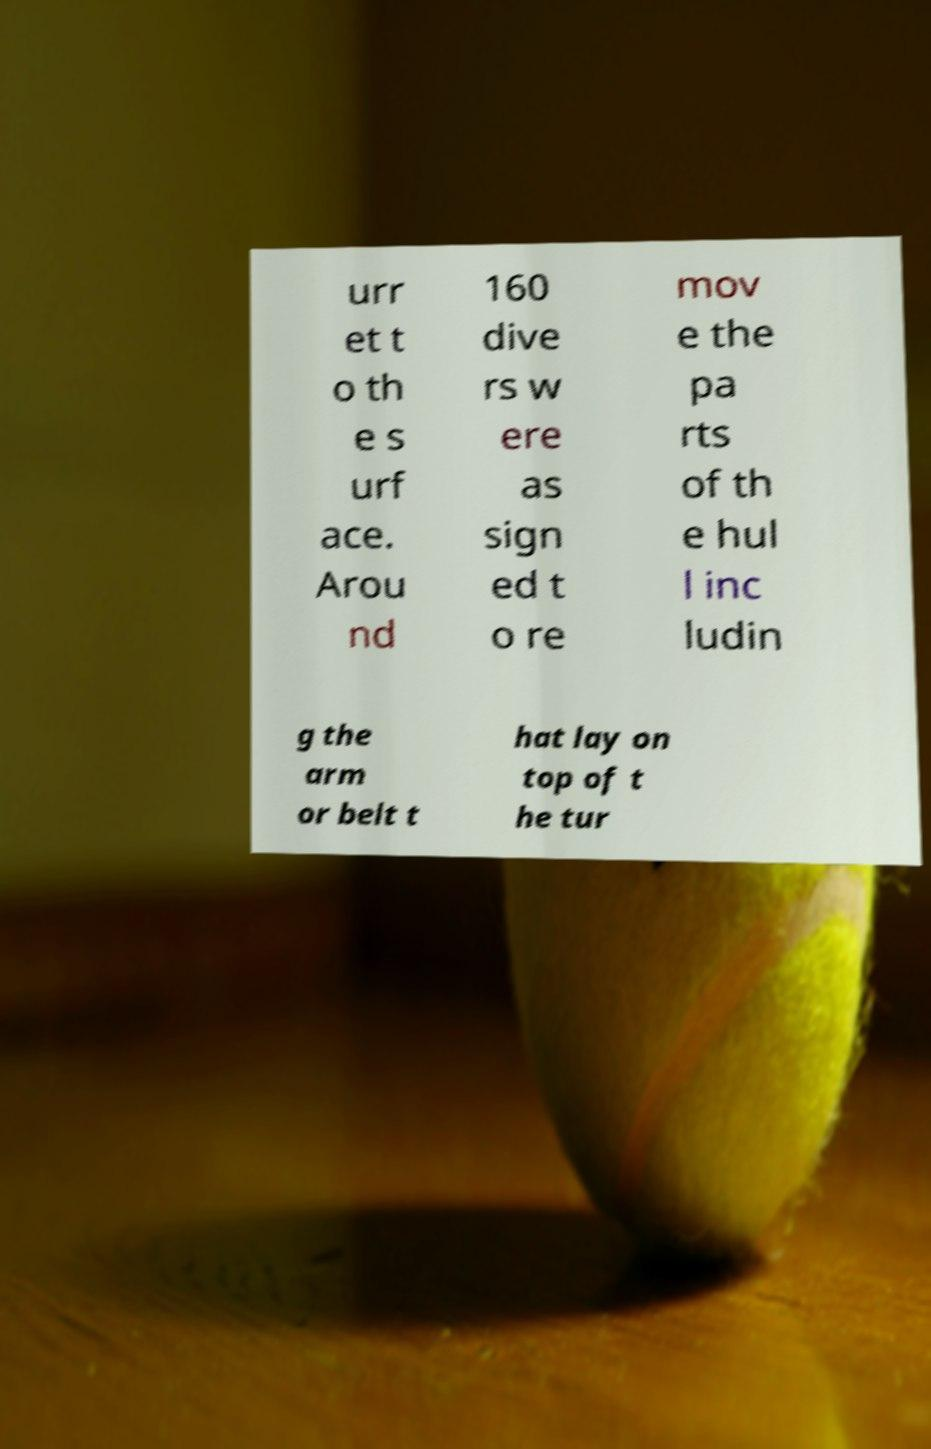What messages or text are displayed in this image? I need them in a readable, typed format. urr et t o th e s urf ace. Arou nd 160 dive rs w ere as sign ed t o re mov e the pa rts of th e hul l inc ludin g the arm or belt t hat lay on top of t he tur 